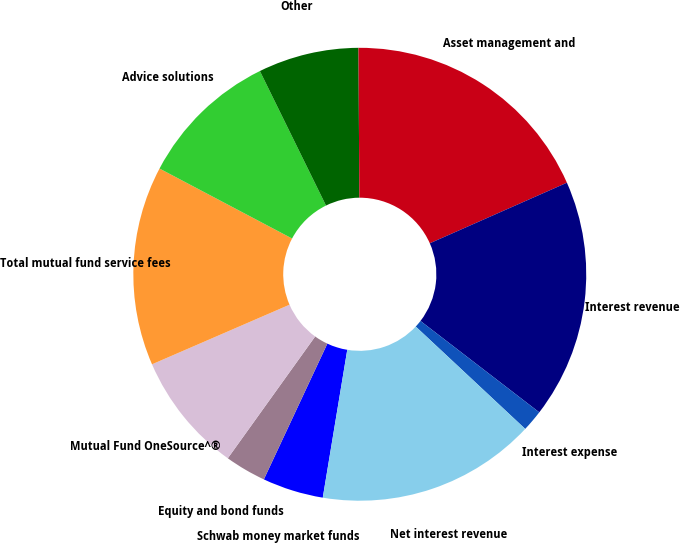Convert chart. <chart><loc_0><loc_0><loc_500><loc_500><pie_chart><fcel>Schwab money market funds<fcel>Equity and bond funds<fcel>Mutual Fund OneSource^®<fcel>Total mutual fund service fees<fcel>Advice solutions<fcel>Other<fcel>Asset management and<fcel>Interest revenue<fcel>Interest expense<fcel>Net interest revenue<nl><fcel>4.35%<fcel>2.94%<fcel>8.59%<fcel>14.24%<fcel>10.0%<fcel>7.18%<fcel>18.47%<fcel>17.06%<fcel>1.53%<fcel>15.65%<nl></chart> 